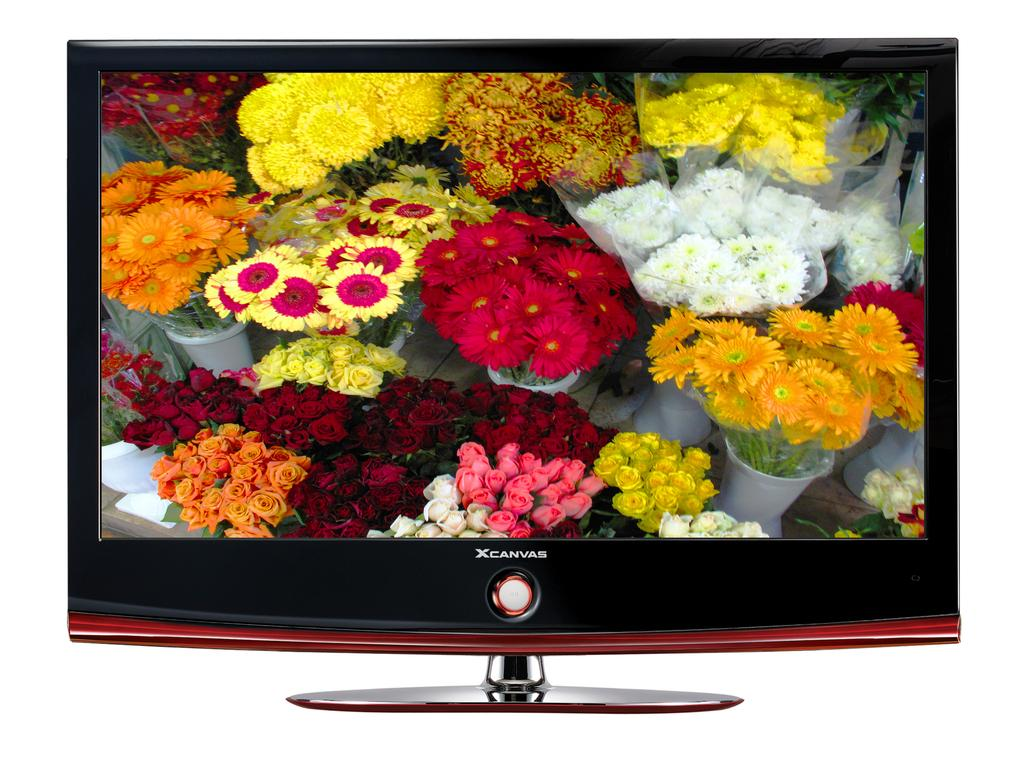<image>
Relay a brief, clear account of the picture shown. a tv that has the word canvas on it 